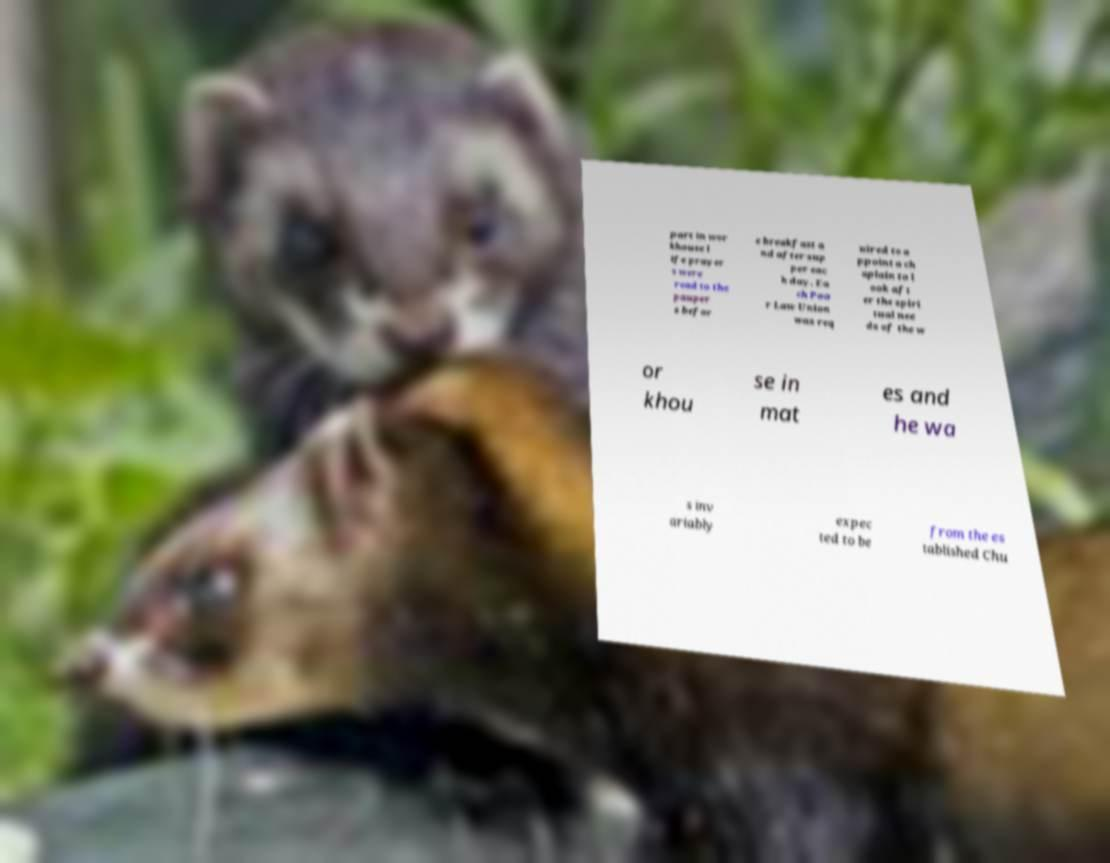Can you read and provide the text displayed in the image?This photo seems to have some interesting text. Can you extract and type it out for me? part in wor khouse l ife prayer s were read to the pauper s befor e breakfast a nd after sup per eac h day. Ea ch Poo r Law Union was req uired to a ppoint a ch aplain to l ook aft er the spiri tual nee ds of the w or khou se in mat es and he wa s inv ariably expec ted to be from the es tablished Chu 